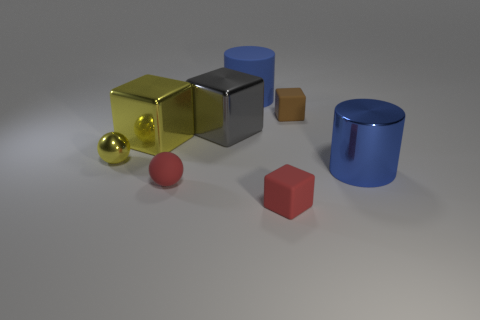Subtract all big gray cubes. How many cubes are left? 3 Add 1 blocks. How many objects exist? 9 Subtract all yellow spheres. How many spheres are left? 1 Subtract all spheres. How many objects are left? 6 Subtract 0 purple spheres. How many objects are left? 8 Subtract 1 cylinders. How many cylinders are left? 1 Subtract all yellow cubes. Subtract all brown cylinders. How many cubes are left? 3 Subtract all big yellow metallic objects. Subtract all blue things. How many objects are left? 5 Add 5 brown cubes. How many brown cubes are left? 6 Add 6 small metal balls. How many small metal balls exist? 7 